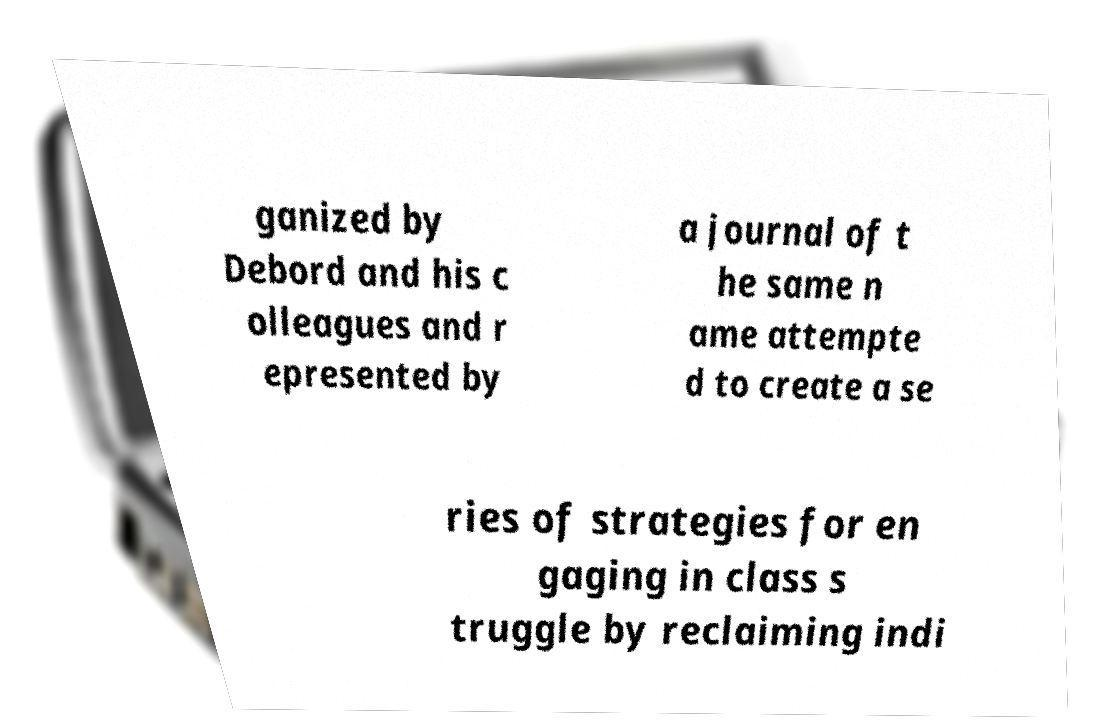Could you extract and type out the text from this image? ganized by Debord and his c olleagues and r epresented by a journal of t he same n ame attempte d to create a se ries of strategies for en gaging in class s truggle by reclaiming indi 